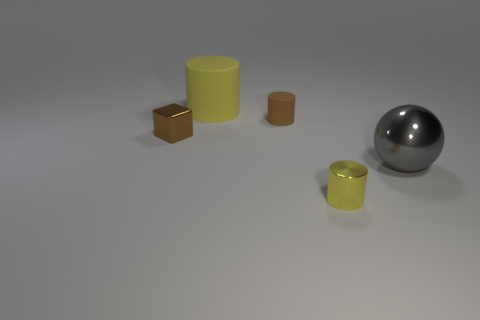Are there any tiny rubber objects that have the same color as the shiny block?
Make the answer very short. Yes. There is a metal thing left of the small yellow object; does it have the same color as the small rubber cylinder?
Offer a terse response. Yes. There is a large cylinder that is the same color as the tiny metallic cylinder; what material is it?
Provide a short and direct response. Rubber. There is a rubber object that is the same color as the tiny shiny cylinder; what is its size?
Offer a very short reply. Large. There is a large object behind the gray ball; does it have the same color as the tiny shiny thing in front of the large gray shiny sphere?
Offer a terse response. Yes. Are there more cylinders in front of the metal cylinder than tiny brown metal objects?
Your response must be concise. No. What is the small brown cylinder made of?
Make the answer very short. Rubber. How many other gray spheres are the same size as the gray shiny ball?
Your answer should be compact. 0. Are there the same number of metallic things that are on the right side of the cube and objects that are on the right side of the tiny matte thing?
Your answer should be compact. Yes. Do the big sphere and the large yellow object have the same material?
Ensure brevity in your answer.  No. 